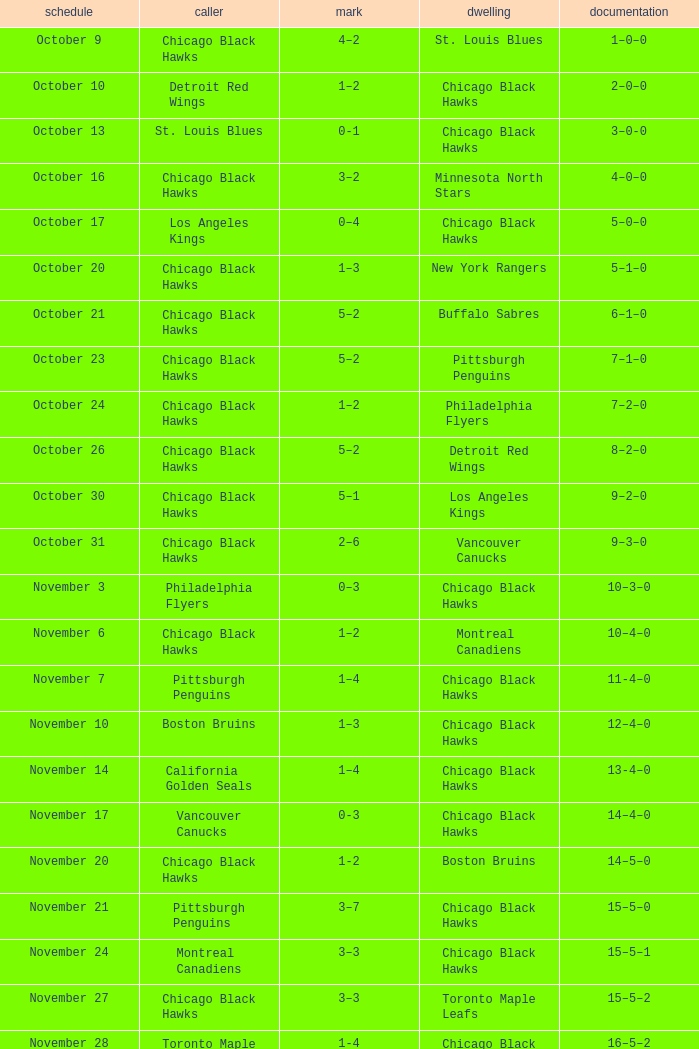What is the Record of the February 26 date? 39–16–7. 